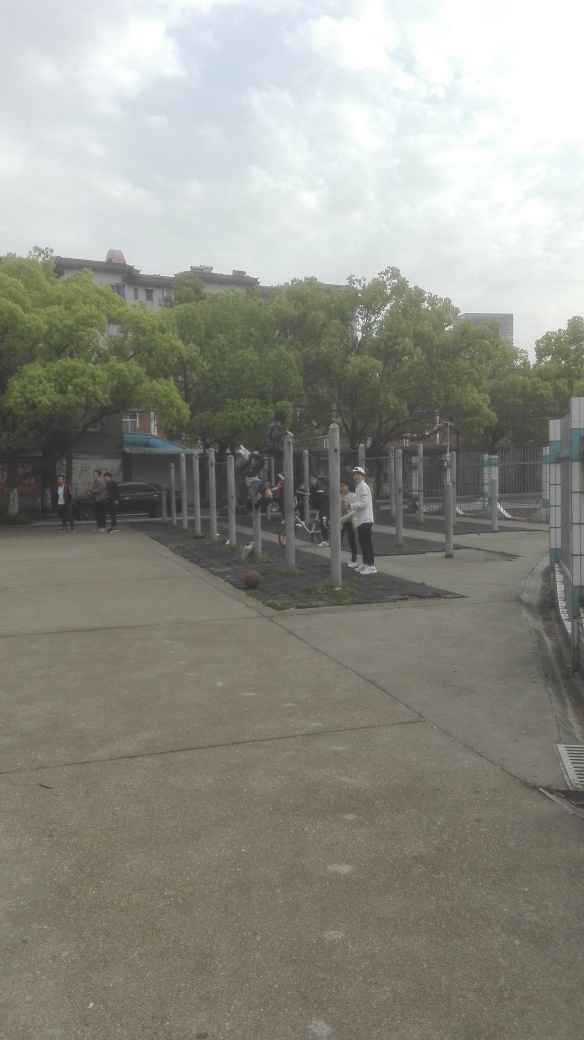Are there any compression artifacts visible? Based on the quality of the image, there are slight signs of compression, notably in the less detailed areas like the sky and in the shadows. These artifacts manifest as subtle blockiness or blurriness, potentially reducing the overall clarity of the image. 